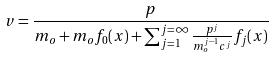<formula> <loc_0><loc_0><loc_500><loc_500>v = \frac { p } { m _ { o } + m _ { o } f _ { 0 } ( x ) + \sum _ { j = 1 } ^ { j = \infty } \frac { p ^ { j } } { m _ { o } ^ { j - 1 } c ^ { j } } f _ { j } ( x ) }</formula> 